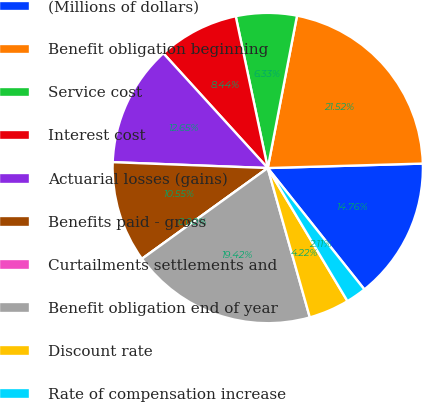<chart> <loc_0><loc_0><loc_500><loc_500><pie_chart><fcel>(Millions of dollars)<fcel>Benefit obligation beginning<fcel>Service cost<fcel>Interest cost<fcel>Actuarial losses (gains)<fcel>Benefits paid - gross<fcel>Curtailments settlements and<fcel>Benefit obligation end of year<fcel>Discount rate<fcel>Rate of compensation increase<nl><fcel>14.76%<fcel>21.52%<fcel>6.33%<fcel>8.44%<fcel>12.65%<fcel>10.55%<fcel>0.0%<fcel>19.42%<fcel>4.22%<fcel>2.11%<nl></chart> 